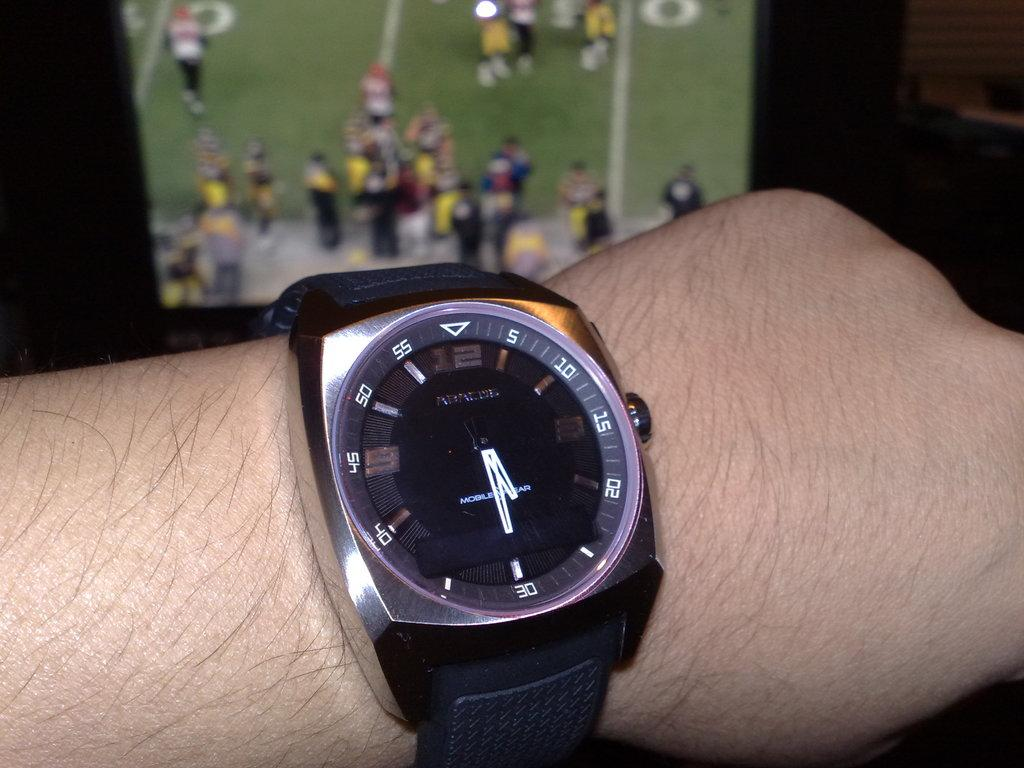<image>
Render a clear and concise summary of the photo. The minute hand of the watch pointed at 30 minutes. 